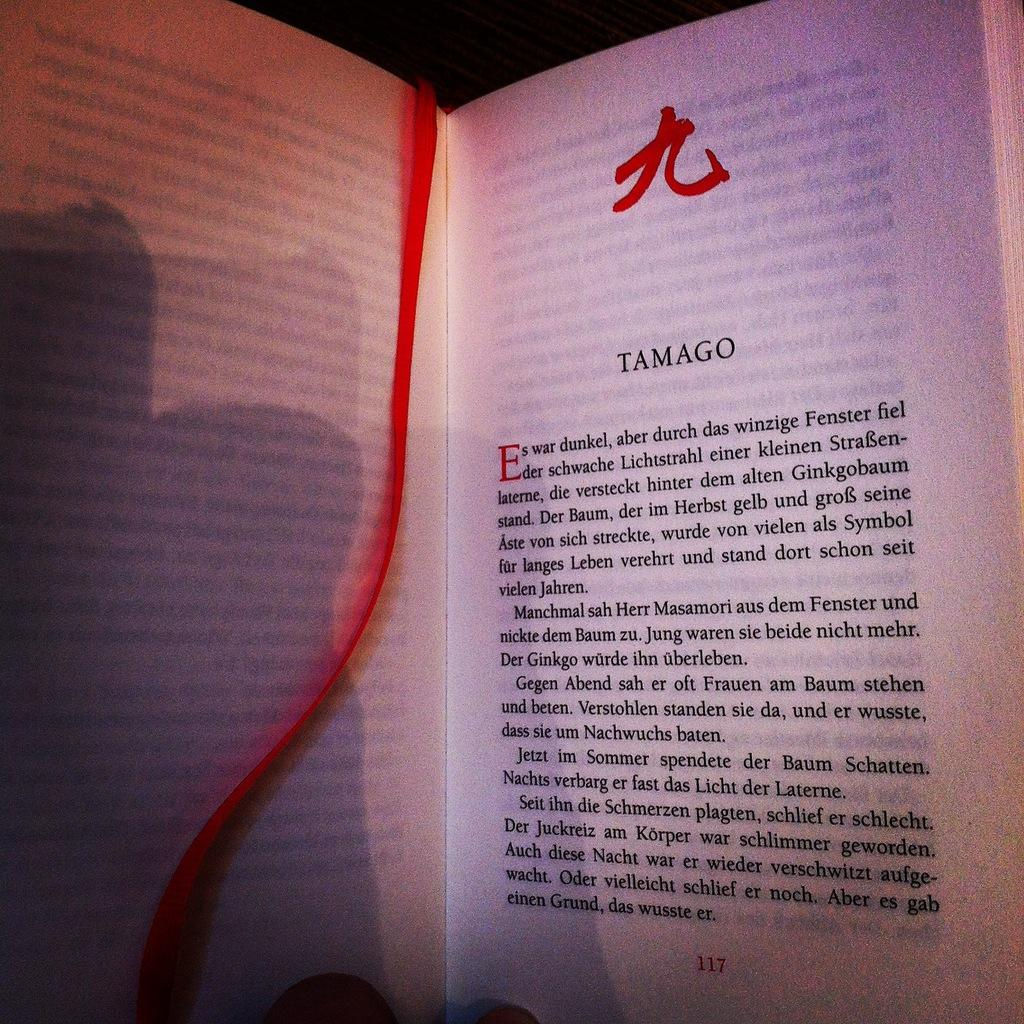<image>
Summarize the visual content of the image. a page in a book that says 'tamago' as the title of it 